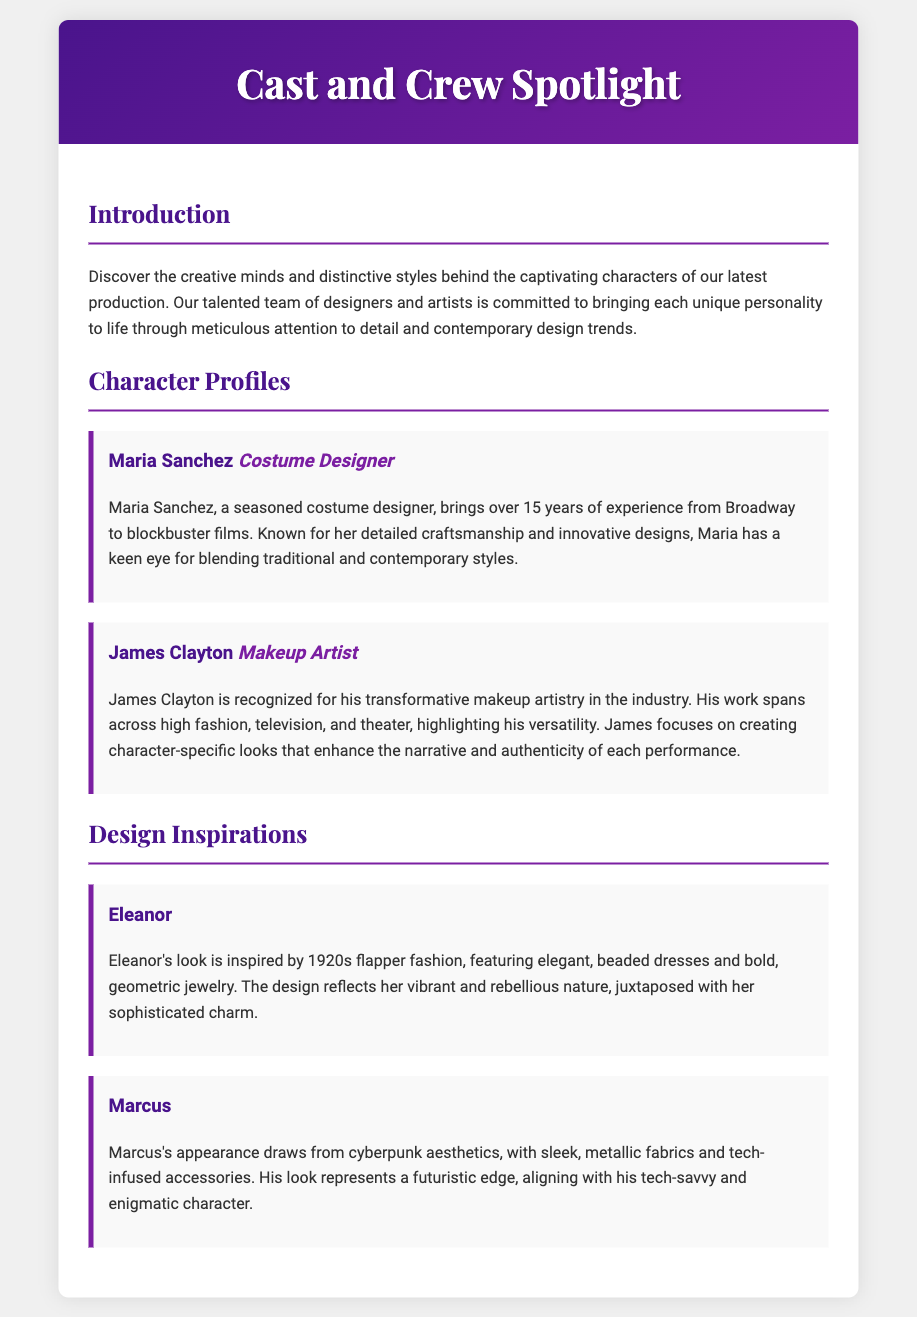What is the title of the document? The title of the document is displayed prominently at the top of the Playbill.
Answer: Cast and Crew Spotlight Who is the costume designer? The document lists the individual responsible for costume design in the character profiles section.
Answer: Maria Sanchez How many years of experience does Maria Sanchez have? The document mentions Maria's experience in the industry to indicate her expertise.
Answer: 15 years What inspired Eleanor's look? The document describes specific fashion trends that influenced the character's design.
Answer: 1920s flapper fashion What is a key characteristic of Marcus's appearance? The document outlines various design elements that define Marcus's aesthetic.
Answer: Cyberpunk aesthetics Who is the makeup artist featured in the profiles? The name of the makeup artist is provided in the character profiles section of the Playbill.
Answer: James Clayton Which section discusses character designs? The document organizes content into sections, one of which is focused on character designs.
Answer: Design Inspirations What color is the header background? The document describes the header's design, including its color scheme.
Answer: Gradient of purple What is James Clayton known for? The document explains the makeup artist's recognizable qualities and his professional focus.
Answer: Transformative makeup artistry 